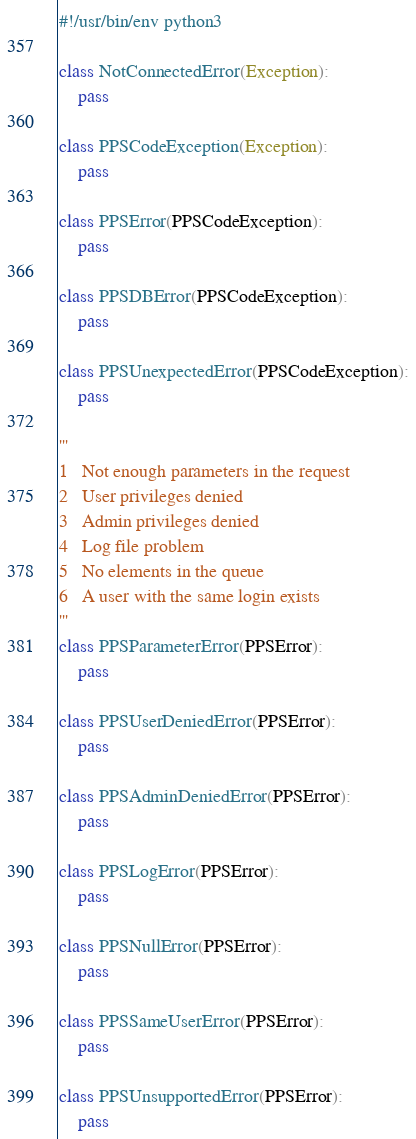<code> <loc_0><loc_0><loc_500><loc_500><_Python_>#!/usr/bin/env python3

class NotConnectedError(Exception):
    pass

class PPSCodeException(Exception):
    pass

class PPSError(PPSCodeException):
    pass

class PPSDBError(PPSCodeException):
    pass

class PPSUnexpectedError(PPSCodeException):
    pass

'''
1   Not enough parameters in the request
2   User privileges denied
3   Admin privileges denied
4   Log file problem
5   No elements in the queue
6   A user with the same login exists
'''
class PPSParameterError(PPSError):
    pass

class PPSUserDeniedError(PPSError):
    pass

class PPSAdminDeniedError(PPSError):
    pass

class PPSLogError(PPSError):
    pass

class PPSNullError(PPSError):
    pass

class PPSSameUserError(PPSError):
    pass

class PPSUnsupportedError(PPSError):
    pass
</code> 